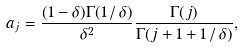<formula> <loc_0><loc_0><loc_500><loc_500>a _ { j } = \frac { ( 1 - \delta ) \Gamma ( 1 \, / \, \delta ) } { \delta ^ { 2 } } \frac { \Gamma ( j ) } { \Gamma ( j + 1 + 1 \, / \, \delta ) } ,</formula> 